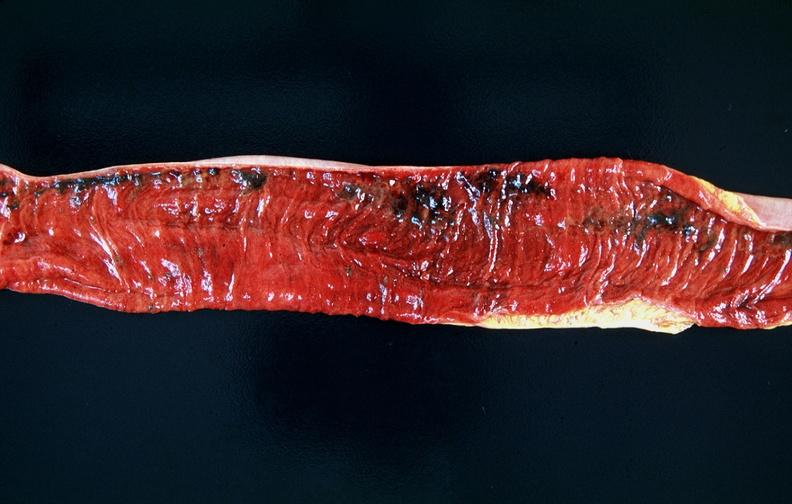s metastatic carcinoma prostate present?
Answer the question using a single word or phrase. No 